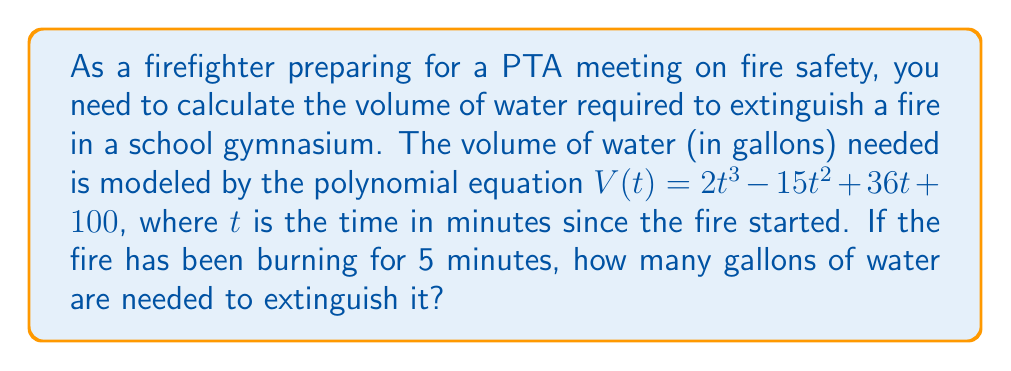Provide a solution to this math problem. To solve this problem, we need to evaluate the polynomial $V(t)$ at $t = 5$. Let's break it down step-by-step:

1. Given polynomial: $V(t) = 2t^3 - 15t^2 + 36t + 100$

2. Substitute $t = 5$ into the equation:
   $V(5) = 2(5^3) - 15(5^2) + 36(5) + 100$

3. Evaluate the exponents:
   $V(5) = 2(125) - 15(25) + 36(5) + 100$

4. Multiply:
   $V(5) = 250 - 375 + 180 + 100$

5. Add and subtract from left to right:
   $V(5) = -125 + 180 + 100$
   $V(5) = 55 + 100$
   $V(5) = 155$

Therefore, after 5 minutes, 155 gallons of water are needed to extinguish the fire.
Answer: 155 gallons 